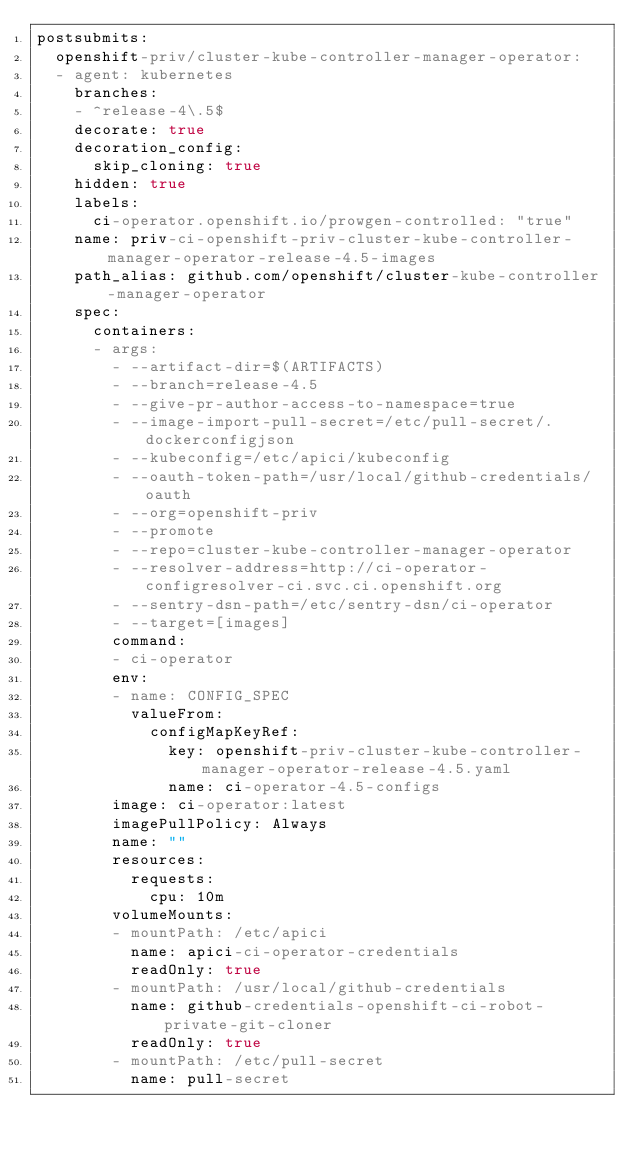Convert code to text. <code><loc_0><loc_0><loc_500><loc_500><_YAML_>postsubmits:
  openshift-priv/cluster-kube-controller-manager-operator:
  - agent: kubernetes
    branches:
    - ^release-4\.5$
    decorate: true
    decoration_config:
      skip_cloning: true
    hidden: true
    labels:
      ci-operator.openshift.io/prowgen-controlled: "true"
    name: priv-ci-openshift-priv-cluster-kube-controller-manager-operator-release-4.5-images
    path_alias: github.com/openshift/cluster-kube-controller-manager-operator
    spec:
      containers:
      - args:
        - --artifact-dir=$(ARTIFACTS)
        - --branch=release-4.5
        - --give-pr-author-access-to-namespace=true
        - --image-import-pull-secret=/etc/pull-secret/.dockerconfigjson
        - --kubeconfig=/etc/apici/kubeconfig
        - --oauth-token-path=/usr/local/github-credentials/oauth
        - --org=openshift-priv
        - --promote
        - --repo=cluster-kube-controller-manager-operator
        - --resolver-address=http://ci-operator-configresolver-ci.svc.ci.openshift.org
        - --sentry-dsn-path=/etc/sentry-dsn/ci-operator
        - --target=[images]
        command:
        - ci-operator
        env:
        - name: CONFIG_SPEC
          valueFrom:
            configMapKeyRef:
              key: openshift-priv-cluster-kube-controller-manager-operator-release-4.5.yaml
              name: ci-operator-4.5-configs
        image: ci-operator:latest
        imagePullPolicy: Always
        name: ""
        resources:
          requests:
            cpu: 10m
        volumeMounts:
        - mountPath: /etc/apici
          name: apici-ci-operator-credentials
          readOnly: true
        - mountPath: /usr/local/github-credentials
          name: github-credentials-openshift-ci-robot-private-git-cloner
          readOnly: true
        - mountPath: /etc/pull-secret
          name: pull-secret</code> 